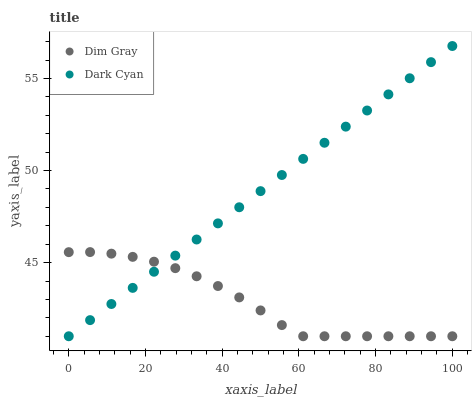Does Dim Gray have the minimum area under the curve?
Answer yes or no. Yes. Does Dark Cyan have the maximum area under the curve?
Answer yes or no. Yes. Does Dim Gray have the maximum area under the curve?
Answer yes or no. No. Is Dark Cyan the smoothest?
Answer yes or no. Yes. Is Dim Gray the roughest?
Answer yes or no. Yes. Is Dim Gray the smoothest?
Answer yes or no. No. Does Dark Cyan have the lowest value?
Answer yes or no. Yes. Does Dark Cyan have the highest value?
Answer yes or no. Yes. Does Dim Gray have the highest value?
Answer yes or no. No. Does Dark Cyan intersect Dim Gray?
Answer yes or no. Yes. Is Dark Cyan less than Dim Gray?
Answer yes or no. No. Is Dark Cyan greater than Dim Gray?
Answer yes or no. No. 